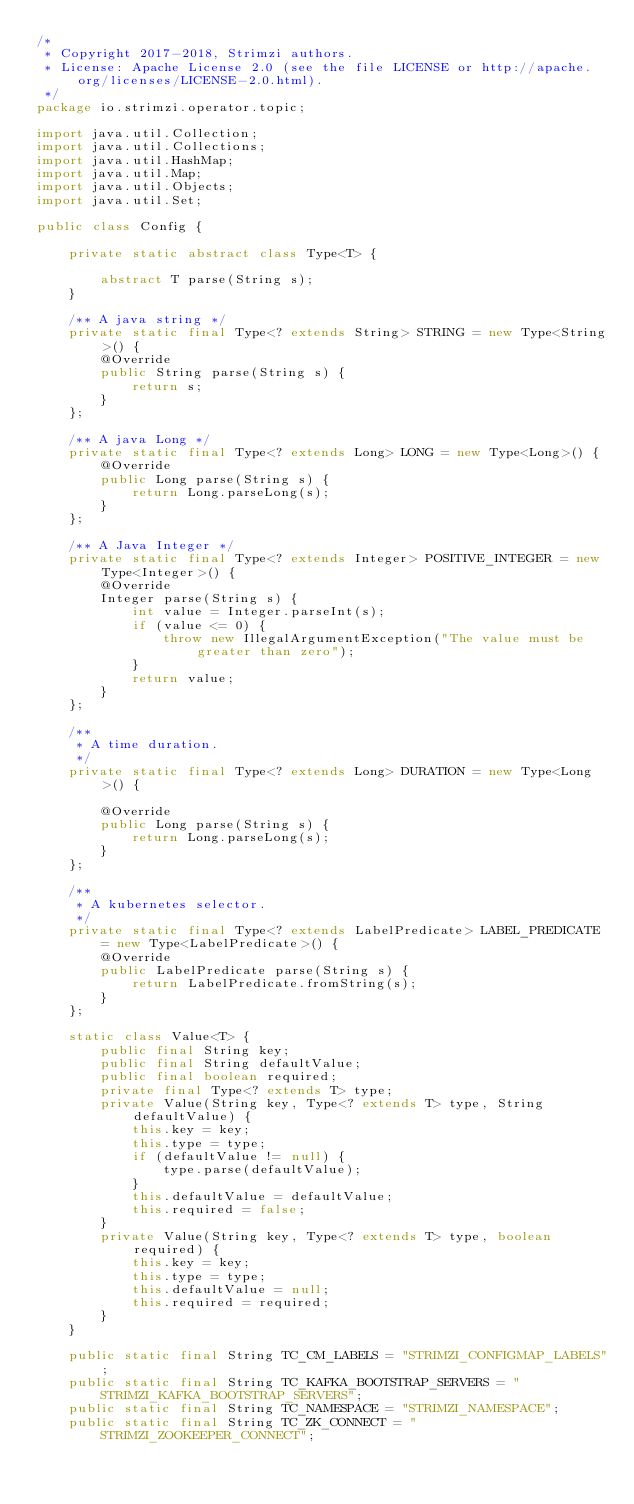<code> <loc_0><loc_0><loc_500><loc_500><_Java_>/*
 * Copyright 2017-2018, Strimzi authors.
 * License: Apache License 2.0 (see the file LICENSE or http://apache.org/licenses/LICENSE-2.0.html).
 */
package io.strimzi.operator.topic;

import java.util.Collection;
import java.util.Collections;
import java.util.HashMap;
import java.util.Map;
import java.util.Objects;
import java.util.Set;

public class Config {

    private static abstract class Type<T> {

        abstract T parse(String s);
    }

    /** A java string */
    private static final Type<? extends String> STRING = new Type<String>() {
        @Override
        public String parse(String s) {
            return s;
        }
    };

    /** A java Long */
    private static final Type<? extends Long> LONG = new Type<Long>() {
        @Override
        public Long parse(String s) {
            return Long.parseLong(s);
        }
    };

    /** A Java Integer */
    private static final Type<? extends Integer> POSITIVE_INTEGER = new Type<Integer>() {
        @Override
        Integer parse(String s) {
            int value = Integer.parseInt(s);
            if (value <= 0) {
                throw new IllegalArgumentException("The value must be greater than zero");
            }
            return value;
        }
    };

    /**
     * A time duration.
     */
    private static final Type<? extends Long> DURATION = new Type<Long>() {

        @Override
        public Long parse(String s) {
            return Long.parseLong(s);
        }
    };

    /**
     * A kubernetes selector.
     */
    private static final Type<? extends LabelPredicate> LABEL_PREDICATE = new Type<LabelPredicate>() {
        @Override
        public LabelPredicate parse(String s) {
            return LabelPredicate.fromString(s);
        }
    };

    static class Value<T> {
        public final String key;
        public final String defaultValue;
        public final boolean required;
        private final Type<? extends T> type;
        private Value(String key, Type<? extends T> type, String defaultValue) {
            this.key = key;
            this.type = type;
            if (defaultValue != null) {
                type.parse(defaultValue);
            }
            this.defaultValue = defaultValue;
            this.required = false;
        }
        private Value(String key, Type<? extends T> type, boolean required) {
            this.key = key;
            this.type = type;
            this.defaultValue = null;
            this.required = required;
        }
    }

    public static final String TC_CM_LABELS = "STRIMZI_CONFIGMAP_LABELS";
    public static final String TC_KAFKA_BOOTSTRAP_SERVERS = "STRIMZI_KAFKA_BOOTSTRAP_SERVERS";
    public static final String TC_NAMESPACE = "STRIMZI_NAMESPACE";
    public static final String TC_ZK_CONNECT = "STRIMZI_ZOOKEEPER_CONNECT";</code> 